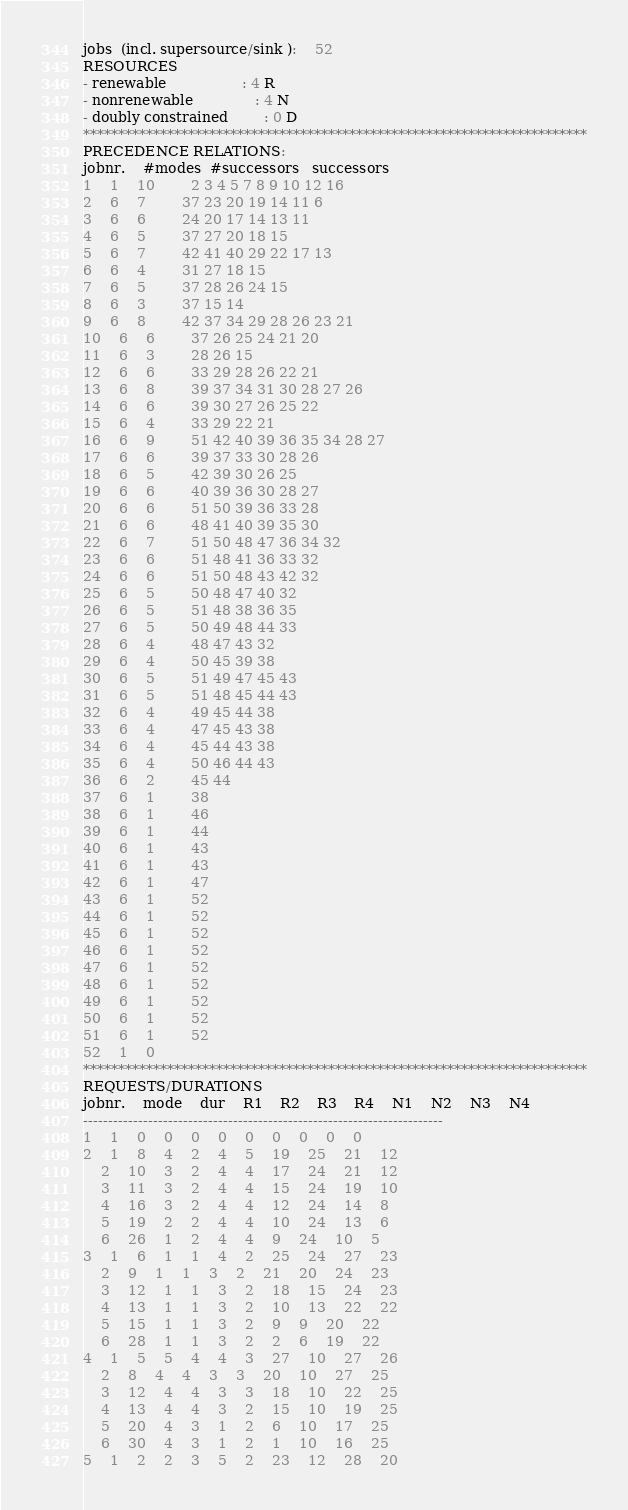<code> <loc_0><loc_0><loc_500><loc_500><_ObjectiveC_>jobs  (incl. supersource/sink ):	52
RESOURCES
- renewable                 : 4 R
- nonrenewable              : 4 N
- doubly constrained        : 0 D
************************************************************************
PRECEDENCE RELATIONS:
jobnr.    #modes  #successors   successors
1	1	10		2 3 4 5 7 8 9 10 12 16 
2	6	7		37 23 20 19 14 11 6 
3	6	6		24 20 17 14 13 11 
4	6	5		37 27 20 18 15 
5	6	7		42 41 40 29 22 17 13 
6	6	4		31 27 18 15 
7	6	5		37 28 26 24 15 
8	6	3		37 15 14 
9	6	8		42 37 34 29 28 26 23 21 
10	6	6		37 26 25 24 21 20 
11	6	3		28 26 15 
12	6	6		33 29 28 26 22 21 
13	6	8		39 37 34 31 30 28 27 26 
14	6	6		39 30 27 26 25 22 
15	6	4		33 29 22 21 
16	6	9		51 42 40 39 36 35 34 28 27 
17	6	6		39 37 33 30 28 26 
18	6	5		42 39 30 26 25 
19	6	6		40 39 36 30 28 27 
20	6	6		51 50 39 36 33 28 
21	6	6		48 41 40 39 35 30 
22	6	7		51 50 48 47 36 34 32 
23	6	6		51 48 41 36 33 32 
24	6	6		51 50 48 43 42 32 
25	6	5		50 48 47 40 32 
26	6	5		51 48 38 36 35 
27	6	5		50 49 48 44 33 
28	6	4		48 47 43 32 
29	6	4		50 45 39 38 
30	6	5		51 49 47 45 43 
31	6	5		51 48 45 44 43 
32	6	4		49 45 44 38 
33	6	4		47 45 43 38 
34	6	4		45 44 43 38 
35	6	4		50 46 44 43 
36	6	2		45 44 
37	6	1		38 
38	6	1		46 
39	6	1		44 
40	6	1		43 
41	6	1		43 
42	6	1		47 
43	6	1		52 
44	6	1		52 
45	6	1		52 
46	6	1		52 
47	6	1		52 
48	6	1		52 
49	6	1		52 
50	6	1		52 
51	6	1		52 
52	1	0		
************************************************************************
REQUESTS/DURATIONS
jobnr.	mode	dur	R1	R2	R3	R4	N1	N2	N3	N4	
------------------------------------------------------------------------
1	1	0	0	0	0	0	0	0	0	0	
2	1	8	4	2	4	5	19	25	21	12	
	2	10	3	2	4	4	17	24	21	12	
	3	11	3	2	4	4	15	24	19	10	
	4	16	3	2	4	4	12	24	14	8	
	5	19	2	2	4	4	10	24	13	6	
	6	26	1	2	4	4	9	24	10	5	
3	1	6	1	1	4	2	25	24	27	23	
	2	9	1	1	3	2	21	20	24	23	
	3	12	1	1	3	2	18	15	24	23	
	4	13	1	1	3	2	10	13	22	22	
	5	15	1	1	3	2	9	9	20	22	
	6	28	1	1	3	2	2	6	19	22	
4	1	5	5	4	4	3	27	10	27	26	
	2	8	4	4	3	3	20	10	27	25	
	3	12	4	4	3	3	18	10	22	25	
	4	13	4	4	3	2	15	10	19	25	
	5	20	4	3	1	2	6	10	17	25	
	6	30	4	3	1	2	1	10	16	25	
5	1	2	2	3	5	2	23	12	28	20	</code> 